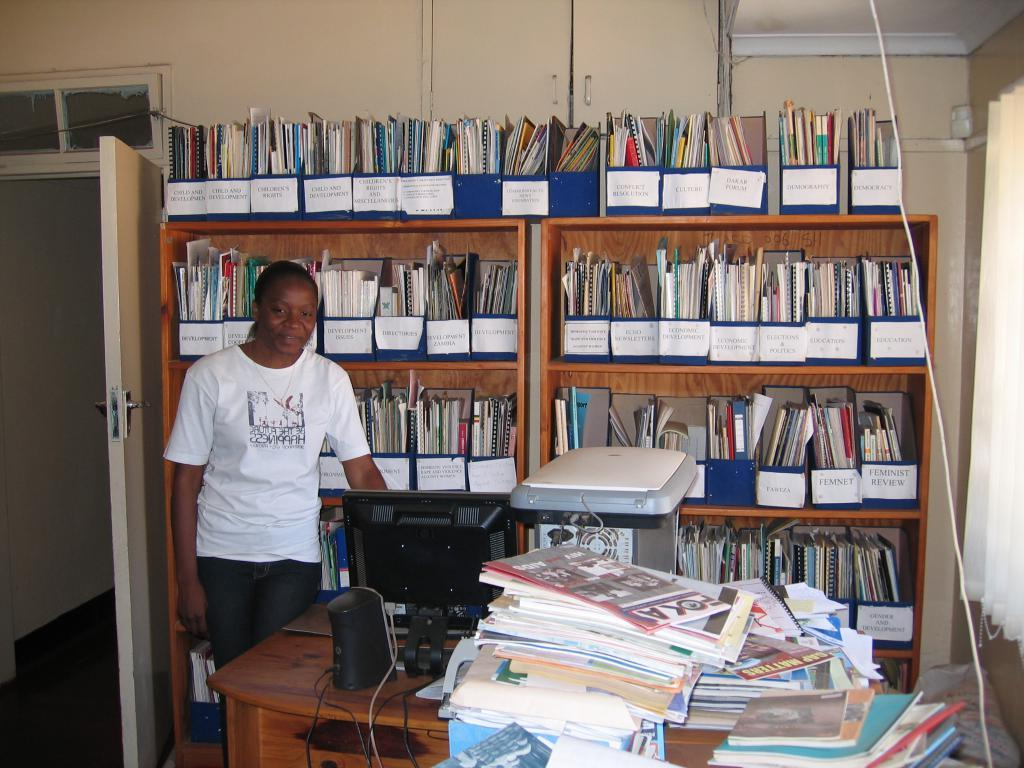<image>
Summarize the visual content of the image. A shelf full of magazines one marked Economic Development. 